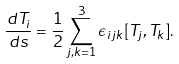<formula> <loc_0><loc_0><loc_500><loc_500>\frac { d T _ { i } } { d s } = \frac { 1 } { 2 } \sum _ { j , k = 1 } ^ { 3 } \epsilon _ { i j k } [ T _ { j } , T _ { k } ] .</formula> 